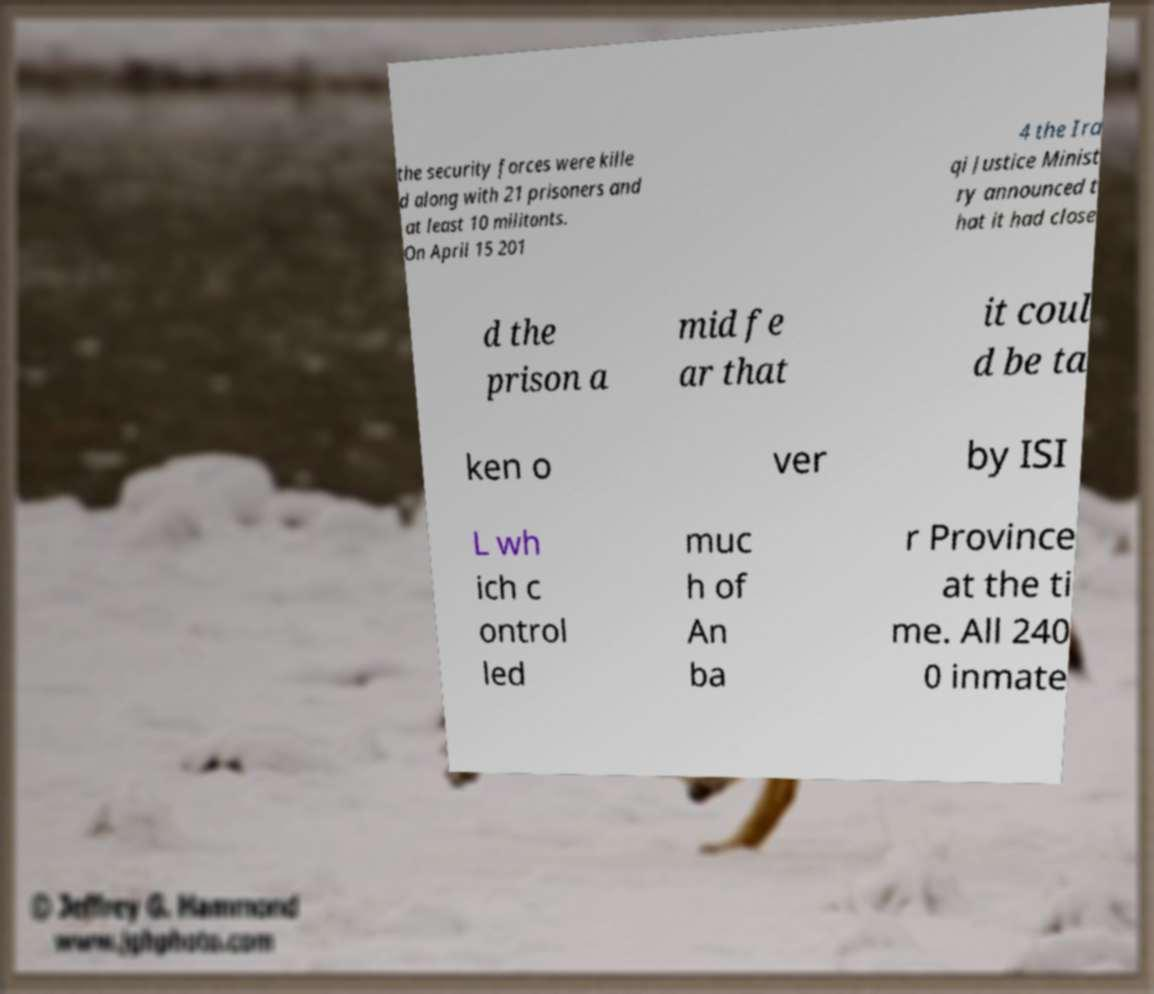There's text embedded in this image that I need extracted. Can you transcribe it verbatim? the security forces were kille d along with 21 prisoners and at least 10 militants. On April 15 201 4 the Ira qi Justice Minist ry announced t hat it had close d the prison a mid fe ar that it coul d be ta ken o ver by ISI L wh ich c ontrol led muc h of An ba r Province at the ti me. All 240 0 inmate 